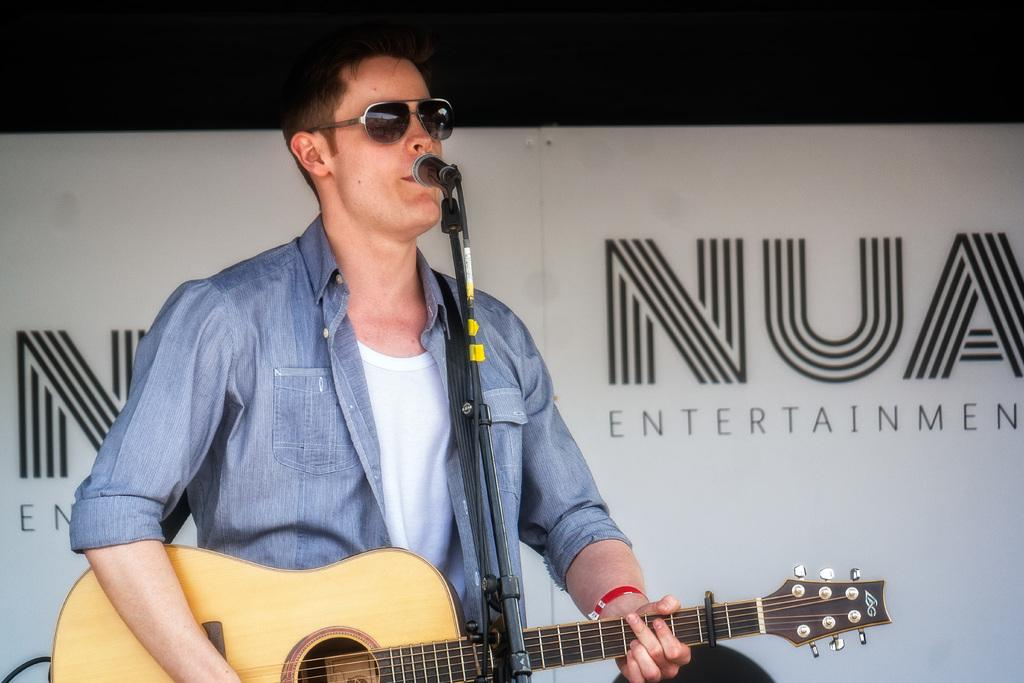What is the man in the image doing? The man is playing a guitar in the image. What object is present in the image that is typically used for amplifying sound? There is a microphone in the image. What type of eyewear is the man wearing? The man is wearing goggles. How many snakes are slithering around the man's feet in the image? There are no snakes present in the image. What type of bed is the man lying on in the image? There is no bed present in the image; the man is standing and playing a guitar. 